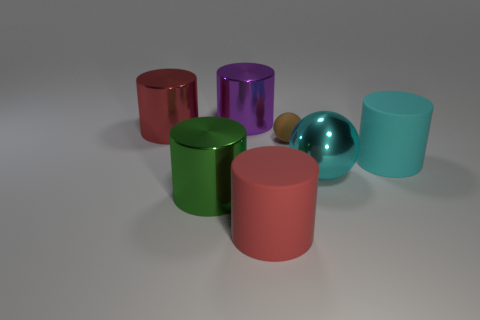Subtract all purple cylinders. How many cylinders are left? 4 Add 2 purple objects. How many objects exist? 9 Subtract 1 spheres. How many spheres are left? 1 Subtract all cyan cylinders. How many cylinders are left? 4 Subtract all yellow spheres. Subtract all purple cubes. How many spheres are left? 2 Subtract all gray spheres. How many green cylinders are left? 1 Add 4 matte things. How many matte things exist? 7 Subtract 1 red cylinders. How many objects are left? 6 Subtract all cylinders. How many objects are left? 2 Subtract all large blocks. Subtract all large red metal things. How many objects are left? 6 